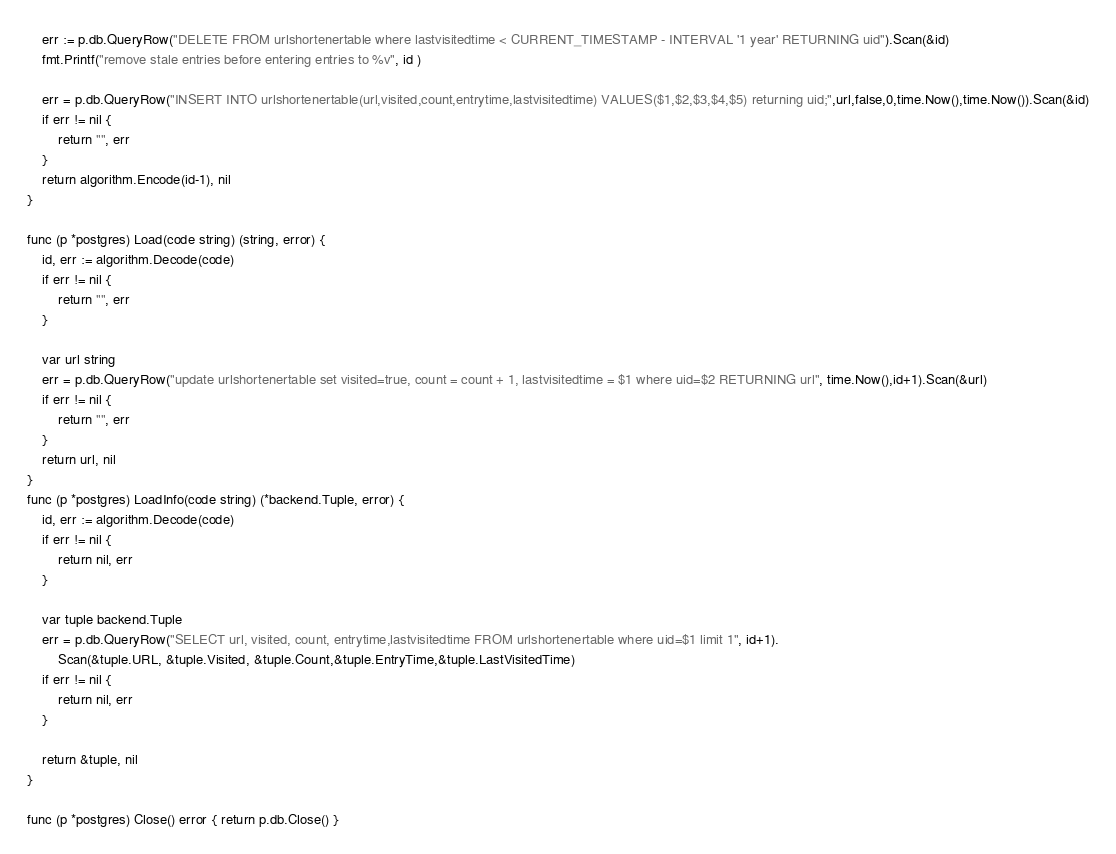Convert code to text. <code><loc_0><loc_0><loc_500><loc_500><_Go_>	err := p.db.QueryRow("DELETE FROM urlshortenertable where lastvisitedtime < CURRENT_TIMESTAMP - INTERVAL '1 year' RETURNING uid").Scan(&id)
	fmt.Printf("remove stale entries before entering entries to %v", id )
	
	err = p.db.QueryRow("INSERT INTO urlshortenertable(url,visited,count,entrytime,lastvisitedtime) VALUES($1,$2,$3,$4,$5) returning uid;",url,false,0,time.Now(),time.Now()).Scan(&id)
	if err != nil {
		return "", err
	}
	return algorithm.Encode(id-1), nil
}

func (p *postgres) Load(code string) (string, error) {
	id, err := algorithm.Decode(code)
	if err != nil {
		return "", err
	}

	var url string
	err = p.db.QueryRow("update urlshortenertable set visited=true, count = count + 1, lastvisitedtime = $1 where uid=$2 RETURNING url", time.Now(),id+1).Scan(&url)
	if err != nil {
		return "", err
	}
	return url, nil
}
func (p *postgres) LoadInfo(code string) (*backend.Tuple, error) {
	id, err := algorithm.Decode(code)
	if err != nil {
		return nil, err
	}

	var tuple backend.Tuple
	err = p.db.QueryRow("SELECT url, visited, count, entrytime,lastvisitedtime FROM urlshortenertable where uid=$1 limit 1", id+1).
		Scan(&tuple.URL, &tuple.Visited, &tuple.Count,&tuple.EntryTime,&tuple.LastVisitedTime)
	if err != nil {
		return nil, err
	}

	return &tuple, nil
}

func (p *postgres) Close() error { return p.db.Close() }
</code> 